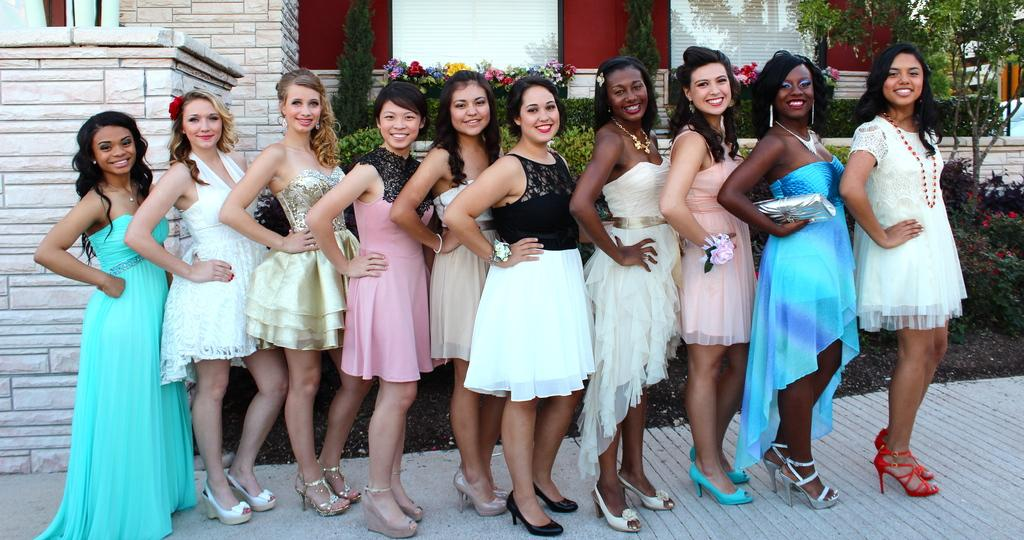How many people are in the image? There is a group of people in the image. What are the people doing in the image? The people are standing. What can be observed about the people's clothing in the image? The people are wearing different color dresses. What type of structure is visible in the image? There is a building in the image. What type of vegetation can be seen in the image? There are flowers and plants in the image. What type of sheet is being used to cover the cracker in the image? There is no sheet or cracker present in the image. 